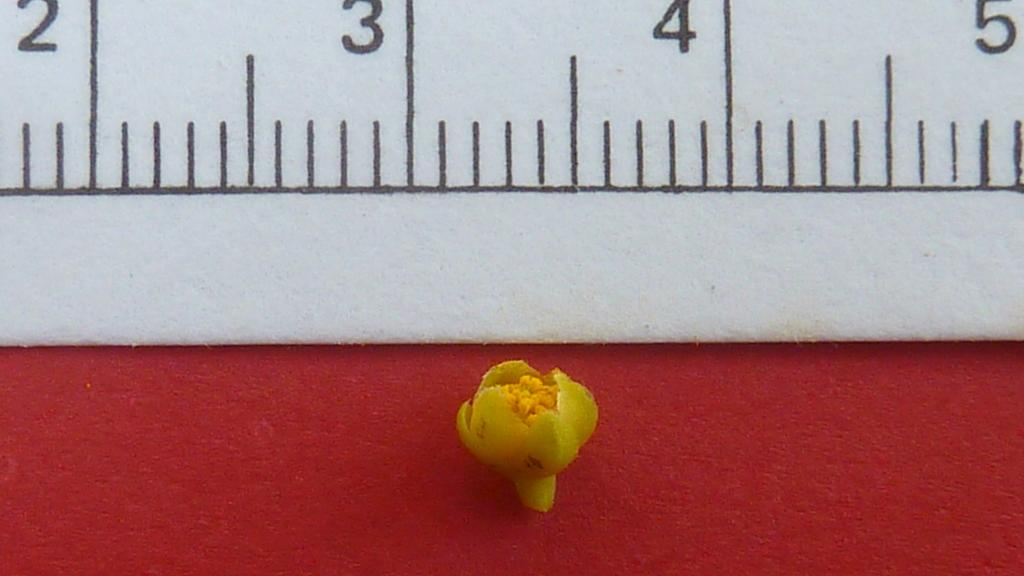<image>
Summarize the visual content of the image. a ruler with a small item beneath it with the numbers 2-5 shown 